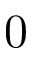Convert formula to latex. <formula><loc_0><loc_0><loc_500><loc_500>0</formula> 